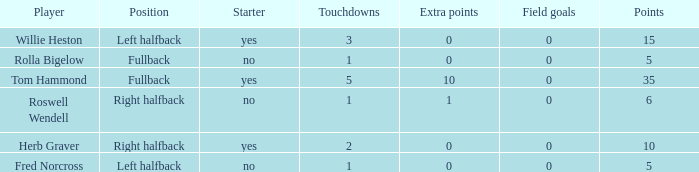How many extra points did right halfback Roswell Wendell have? 1.0. 